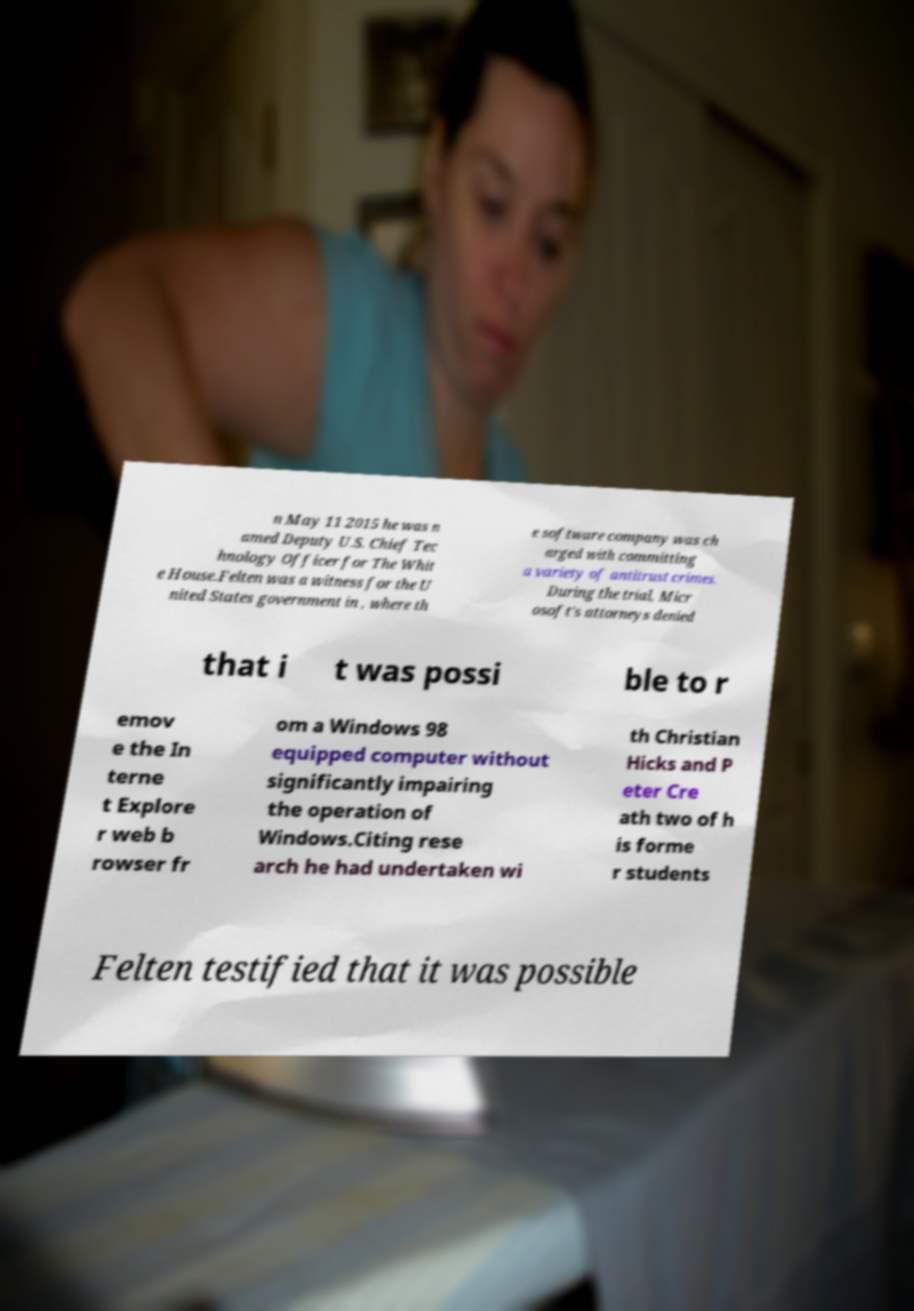Can you accurately transcribe the text from the provided image for me? n May 11 2015 he was n amed Deputy U.S. Chief Tec hnology Officer for The Whit e House.Felten was a witness for the U nited States government in , where th e software company was ch arged with committing a variety of antitrust crimes. During the trial, Micr osoft's attorneys denied that i t was possi ble to r emov e the In terne t Explore r web b rowser fr om a Windows 98 equipped computer without significantly impairing the operation of Windows.Citing rese arch he had undertaken wi th Christian Hicks and P eter Cre ath two of h is forme r students Felten testified that it was possible 